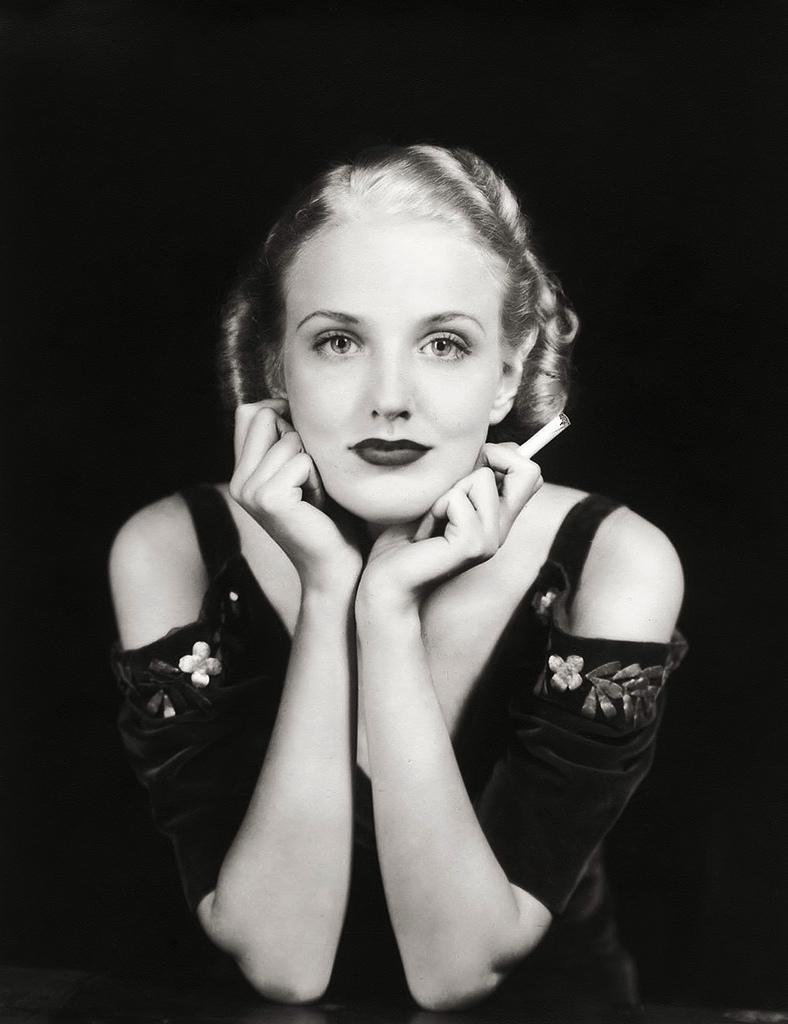What is the color scheme of the image? The image is black and white. Can you describe the main subject in the image? There is a lady in the image. What type of letter is the lady holding in the image? There is no letter present in the image, as it is black and white and only features a lady. How does the lady stop the paste from spreading in the image? There is no paste or indication of spreading in the image; it only features a lady. 